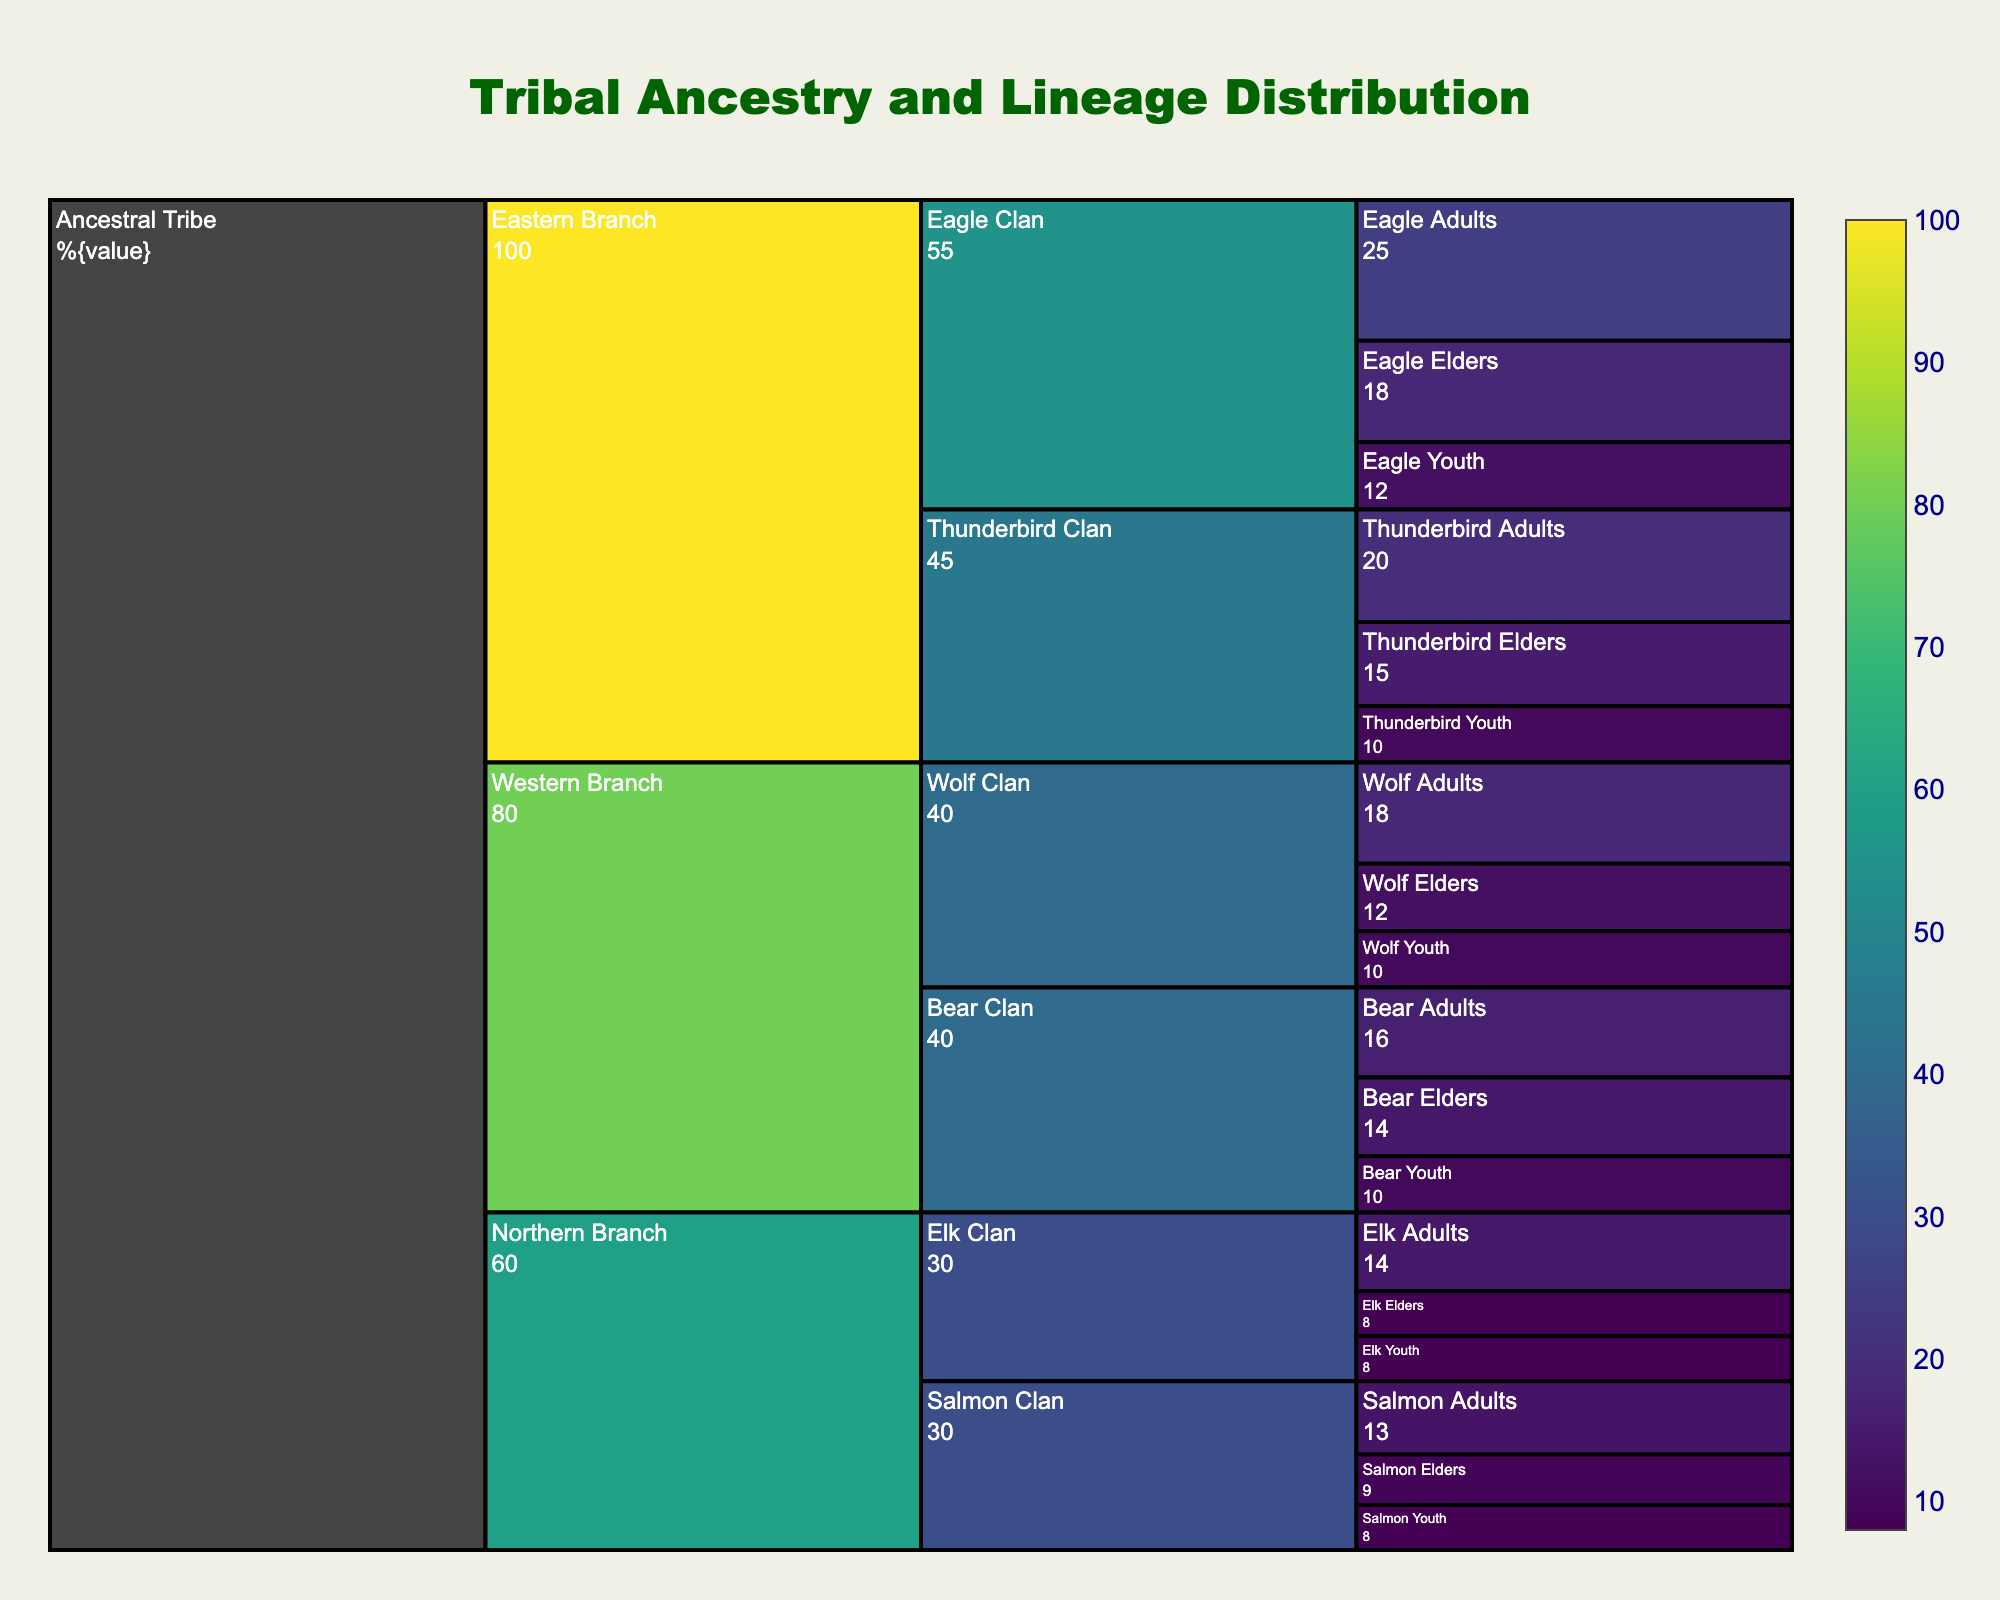What is the title of the figure? The title is usually at the top of the chart and prominently displayed. It provides an overview of what the figure represents.
Answer: Tribal Ancestry and Lineage Distribution What is the population of the Eastern Branch? Looking at the values labeled for the Eastern Branch in the figure, the total value visible for the Eastern Branch is displayed as 100.
Answer: 100 Which clan in the Western Branch has the highest population? Within the Western Branch, compare the population values of the Wolf Clan and Bear Clan. The Bear Clan has a population of 40, the same as the Wolf Clan.
Answer: Both Wolf Clan and Bear Clan What percentage of the Ancestral Tribe does the Northern Branch represent? The total population of the Ancestral Tribe is 240 (100 + 80 + 60). The Northern Branch has a population of 60. So, (60/240) * 100 = 25%.
Answer: 25% How many individuals belong to the Thunderbird Elders group? Locate the Thunderbird Elders group under the Thunderbird Clan and refer to its population value, which is indicated as 15 in the figure.
Answer: 15 Which branch has the smallest total population? Compare the total populations of the Eastern Branch (100), Western Branch (80), and Northern Branch (60). The Northern Branch has the smallest total population.
Answer: Northern Branch What is the cumulative population of all the Elders across the clans? Sum the populations of Elders in all clans: Thunderbird Elders (15) + Eagle Elders (18) + Wolf Elders (12) + Bear Elders (14) + Elk Elders (8) + Salmon Elders (9) = 76.
Answer: 76 Among the Thunderbird, Eagle, and Bear Clans, which one has more adults? Compare the populations of adults in Thunderbird Clan (20), Eagle Clan (25), and Bear Clan (16). The Eagle Clan has the most adults.
Answer: Eagle Clan How does the population of the Wolf Youth compare to the Elk Youth? Look at the population values of Wolf Youth and Elk Youth. Both groups have a population of 10 and 8 respectively. The Wolf Youth have more than the Elk Youth.
Answer: Wolf Youth have more Which group combines to form the total population of the Eastern Branch? The Eastern Branch comprises the Thunderbird Clan (45) and the Eagle Clan (55), giving a total of 45 + 55 = 100.
Answer: Thunderbird Clan and Eagle Clan 